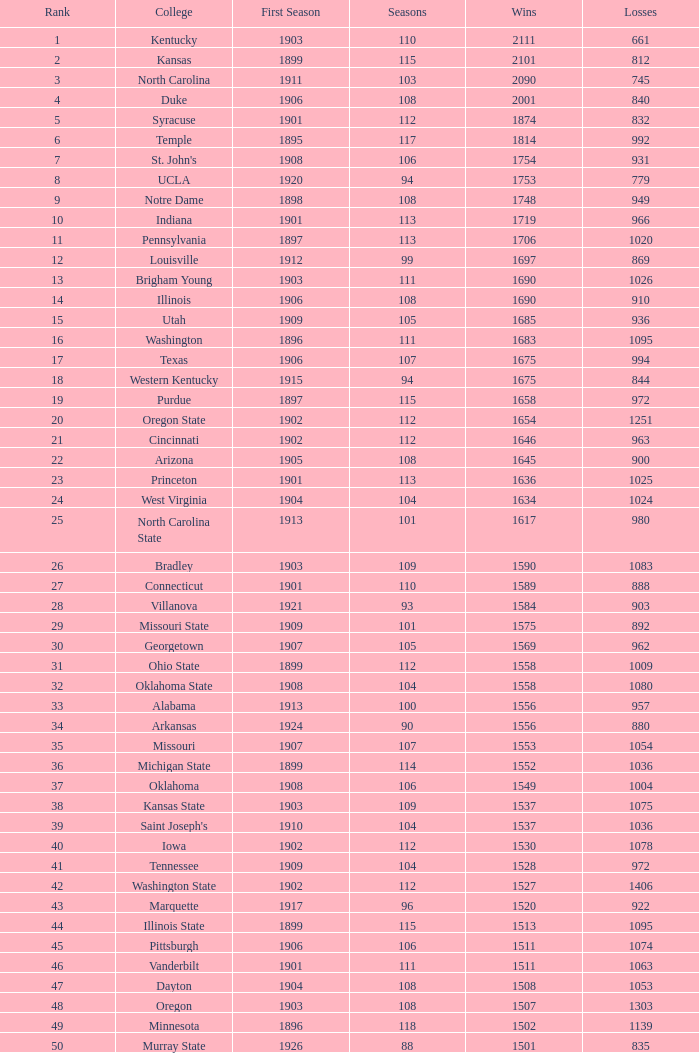Would you mind parsing the complete table? {'header': ['Rank', 'College', 'First Season', 'Seasons', 'Wins', 'Losses'], 'rows': [['1', 'Kentucky', '1903', '110', '2111', '661'], ['2', 'Kansas', '1899', '115', '2101', '812'], ['3', 'North Carolina', '1911', '103', '2090', '745'], ['4', 'Duke', '1906', '108', '2001', '840'], ['5', 'Syracuse', '1901', '112', '1874', '832'], ['6', 'Temple', '1895', '117', '1814', '992'], ['7', "St. John's", '1908', '106', '1754', '931'], ['8', 'UCLA', '1920', '94', '1753', '779'], ['9', 'Notre Dame', '1898', '108', '1748', '949'], ['10', 'Indiana', '1901', '113', '1719', '966'], ['11', 'Pennsylvania', '1897', '113', '1706', '1020'], ['12', 'Louisville', '1912', '99', '1697', '869'], ['13', 'Brigham Young', '1903', '111', '1690', '1026'], ['14', 'Illinois', '1906', '108', '1690', '910'], ['15', 'Utah', '1909', '105', '1685', '936'], ['16', 'Washington', '1896', '111', '1683', '1095'], ['17', 'Texas', '1906', '107', '1675', '994'], ['18', 'Western Kentucky', '1915', '94', '1675', '844'], ['19', 'Purdue', '1897', '115', '1658', '972'], ['20', 'Oregon State', '1902', '112', '1654', '1251'], ['21', 'Cincinnati', '1902', '112', '1646', '963'], ['22', 'Arizona', '1905', '108', '1645', '900'], ['23', 'Princeton', '1901', '113', '1636', '1025'], ['24', 'West Virginia', '1904', '104', '1634', '1024'], ['25', 'North Carolina State', '1913', '101', '1617', '980'], ['26', 'Bradley', '1903', '109', '1590', '1083'], ['27', 'Connecticut', '1901', '110', '1589', '888'], ['28', 'Villanova', '1921', '93', '1584', '903'], ['29', 'Missouri State', '1909', '101', '1575', '892'], ['30', 'Georgetown', '1907', '105', '1569', '962'], ['31', 'Ohio State', '1899', '112', '1558', '1009'], ['32', 'Oklahoma State', '1908', '104', '1558', '1080'], ['33', 'Alabama', '1913', '100', '1556', '957'], ['34', 'Arkansas', '1924', '90', '1556', '880'], ['35', 'Missouri', '1907', '107', '1553', '1054'], ['36', 'Michigan State', '1899', '114', '1552', '1036'], ['37', 'Oklahoma', '1908', '106', '1549', '1004'], ['38', 'Kansas State', '1903', '109', '1537', '1075'], ['39', "Saint Joseph's", '1910', '104', '1537', '1036'], ['40', 'Iowa', '1902', '112', '1530', '1078'], ['41', 'Tennessee', '1909', '104', '1528', '972'], ['42', 'Washington State', '1902', '112', '1527', '1406'], ['43', 'Marquette', '1917', '96', '1520', '922'], ['44', 'Illinois State', '1899', '115', '1513', '1095'], ['45', 'Pittsburgh', '1906', '106', '1511', '1074'], ['46', 'Vanderbilt', '1901', '111', '1511', '1063'], ['47', 'Dayton', '1904', '108', '1508', '1053'], ['48', 'Oregon', '1903', '108', '1507', '1303'], ['49', 'Minnesota', '1896', '118', '1502', '1139'], ['50', 'Murray State', '1926', '88', '1501', '835']]} How many wins were there for Washington State College with losses greater than 980 and a first season before 1906 and rank greater than 42? 0.0. 